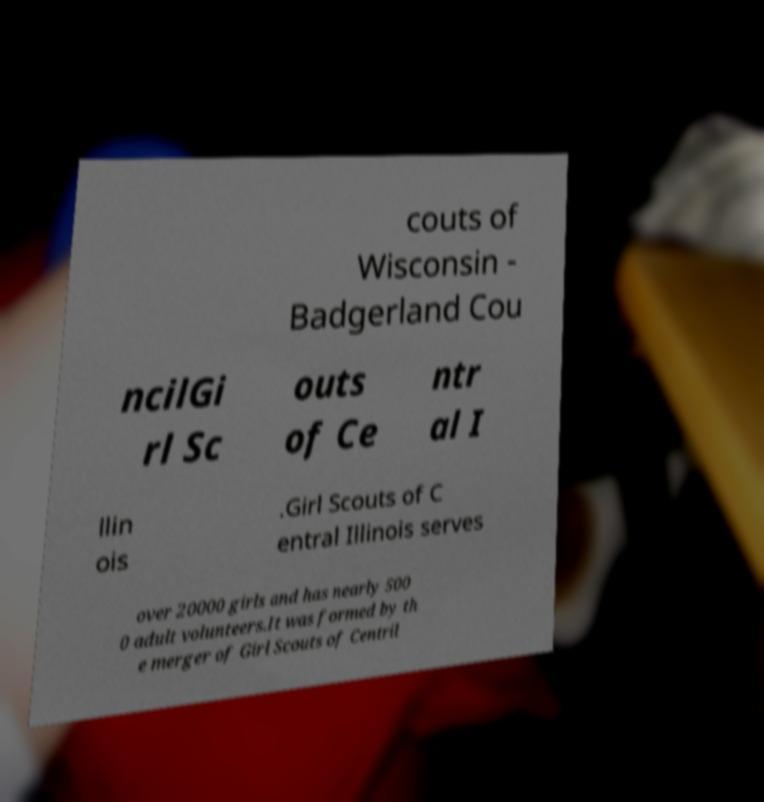Please read and relay the text visible in this image. What does it say? couts of Wisconsin - Badgerland Cou ncilGi rl Sc outs of Ce ntr al I llin ois .Girl Scouts of C entral Illinois serves over 20000 girls and has nearly 500 0 adult volunteers.It was formed by th e merger of Girl Scouts of Centril 